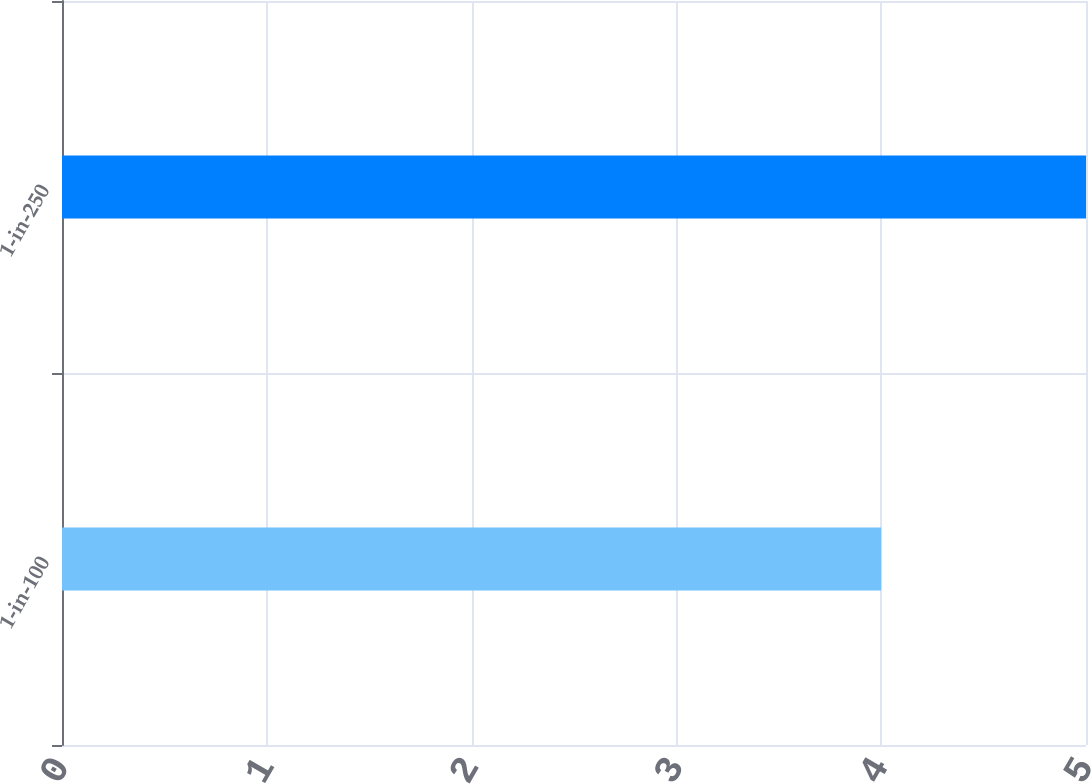Convert chart. <chart><loc_0><loc_0><loc_500><loc_500><bar_chart><fcel>1-in-100<fcel>1-in-250<nl><fcel>4<fcel>5<nl></chart> 